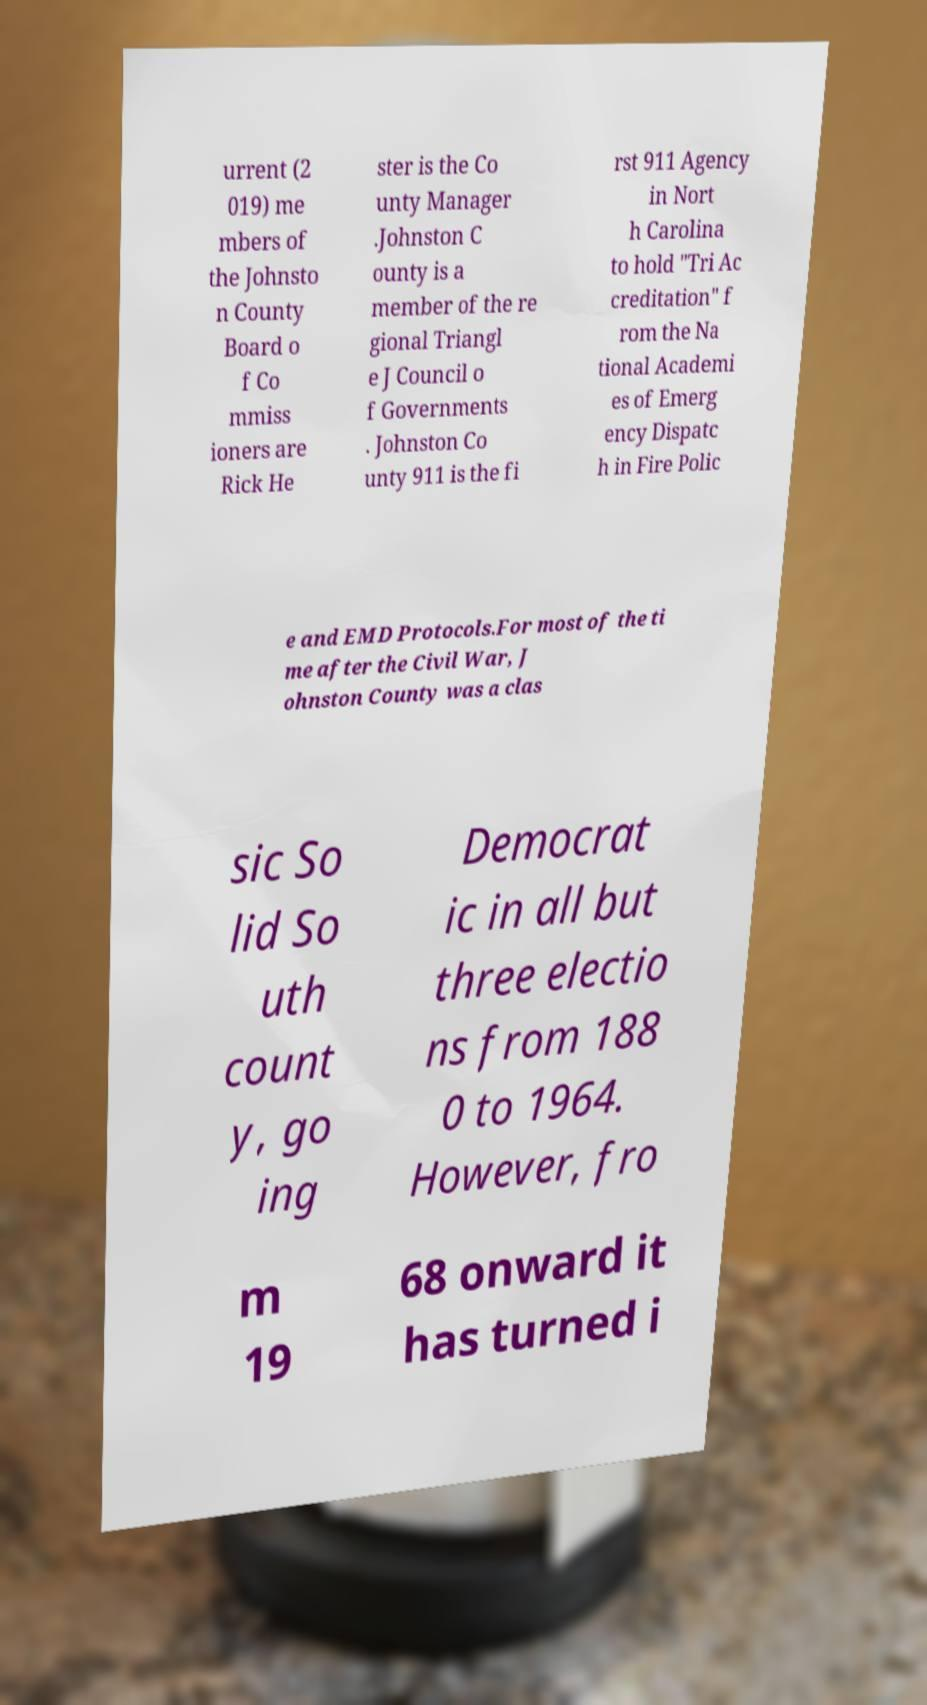There's text embedded in this image that I need extracted. Can you transcribe it verbatim? urrent (2 019) me mbers of the Johnsto n County Board o f Co mmiss ioners are Rick He ster is the Co unty Manager .Johnston C ounty is a member of the re gional Triangl e J Council o f Governments . Johnston Co unty 911 is the fi rst 911 Agency in Nort h Carolina to hold "Tri Ac creditation" f rom the Na tional Academi es of Emerg ency Dispatc h in Fire Polic e and EMD Protocols.For most of the ti me after the Civil War, J ohnston County was a clas sic So lid So uth count y, go ing Democrat ic in all but three electio ns from 188 0 to 1964. However, fro m 19 68 onward it has turned i 